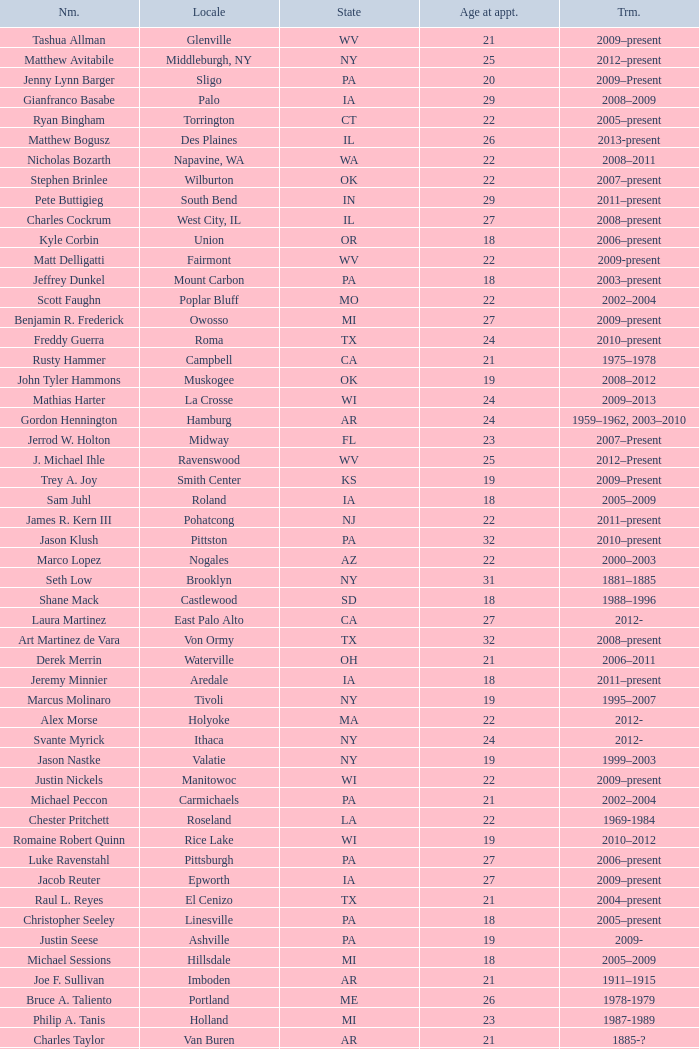What is the name of the holland locale Philip A. Tanis. 